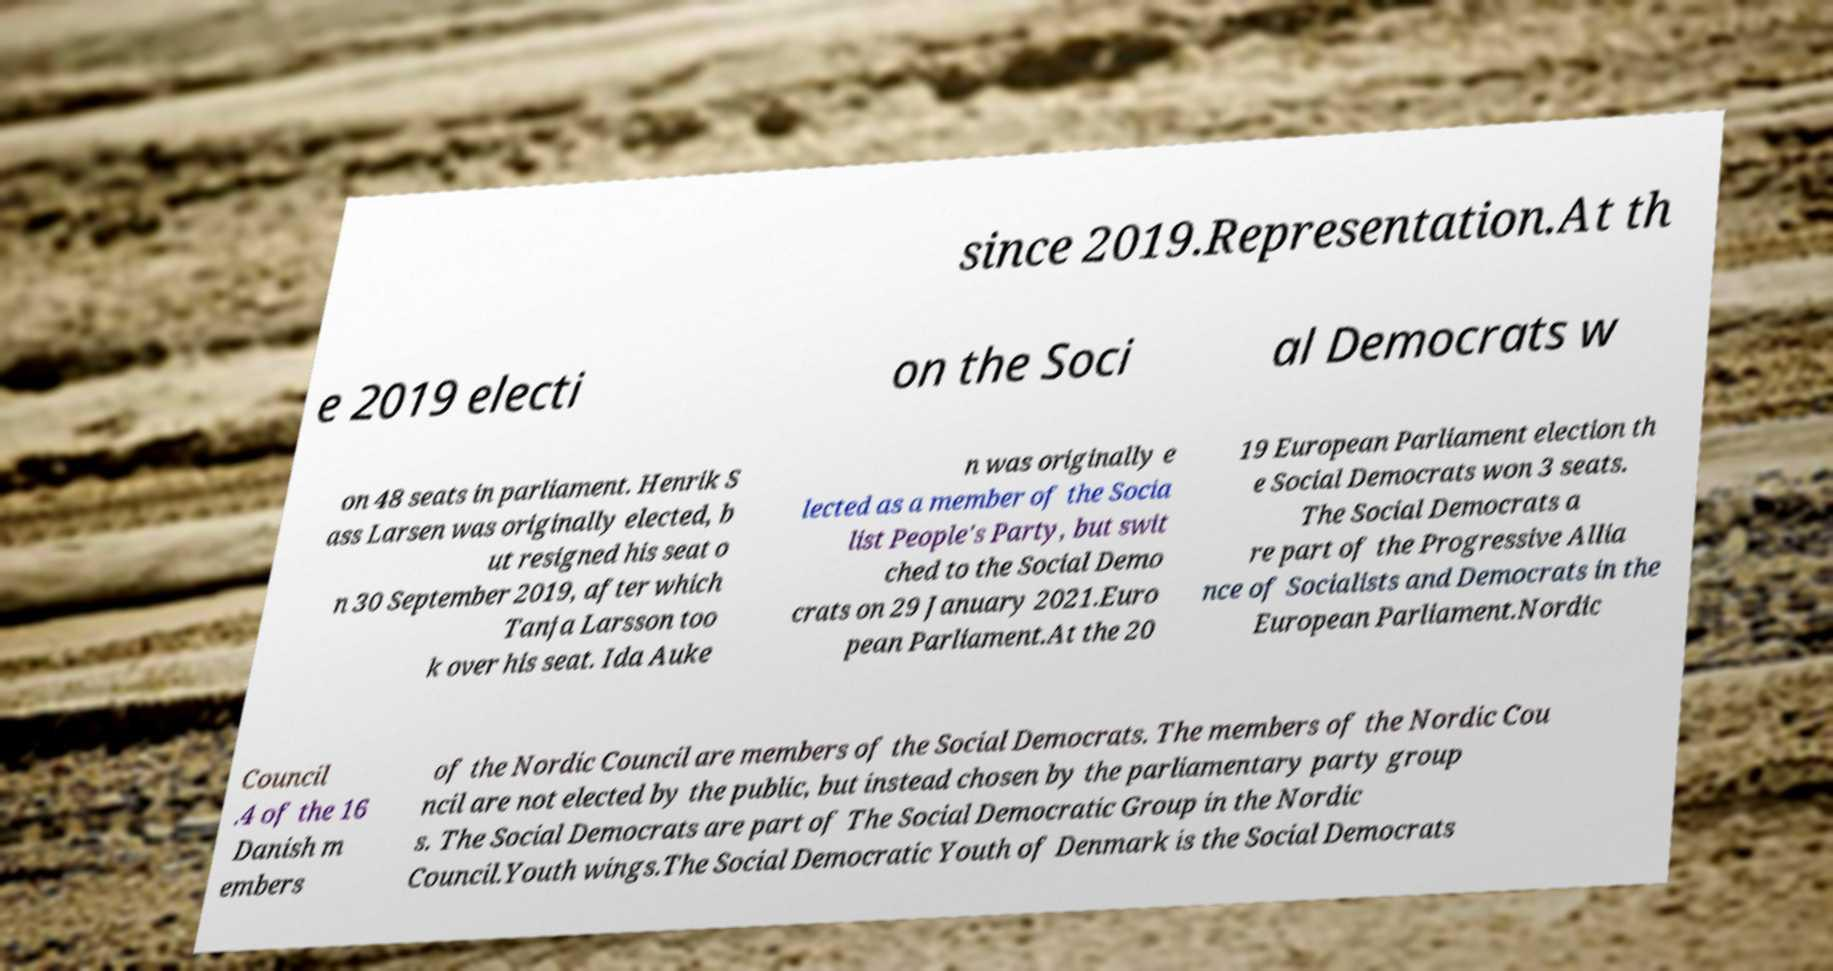Please read and relay the text visible in this image. What does it say? since 2019.Representation.At th e 2019 electi on the Soci al Democrats w on 48 seats in parliament. Henrik S ass Larsen was originally elected, b ut resigned his seat o n 30 September 2019, after which Tanja Larsson too k over his seat. Ida Auke n was originally e lected as a member of the Socia list People's Party, but swit ched to the Social Demo crats on 29 January 2021.Euro pean Parliament.At the 20 19 European Parliament election th e Social Democrats won 3 seats. The Social Democrats a re part of the Progressive Allia nce of Socialists and Democrats in the European Parliament.Nordic Council .4 of the 16 Danish m embers of the Nordic Council are members of the Social Democrats. The members of the Nordic Cou ncil are not elected by the public, but instead chosen by the parliamentary party group s. The Social Democrats are part of The Social Democratic Group in the Nordic Council.Youth wings.The Social Democratic Youth of Denmark is the Social Democrats 